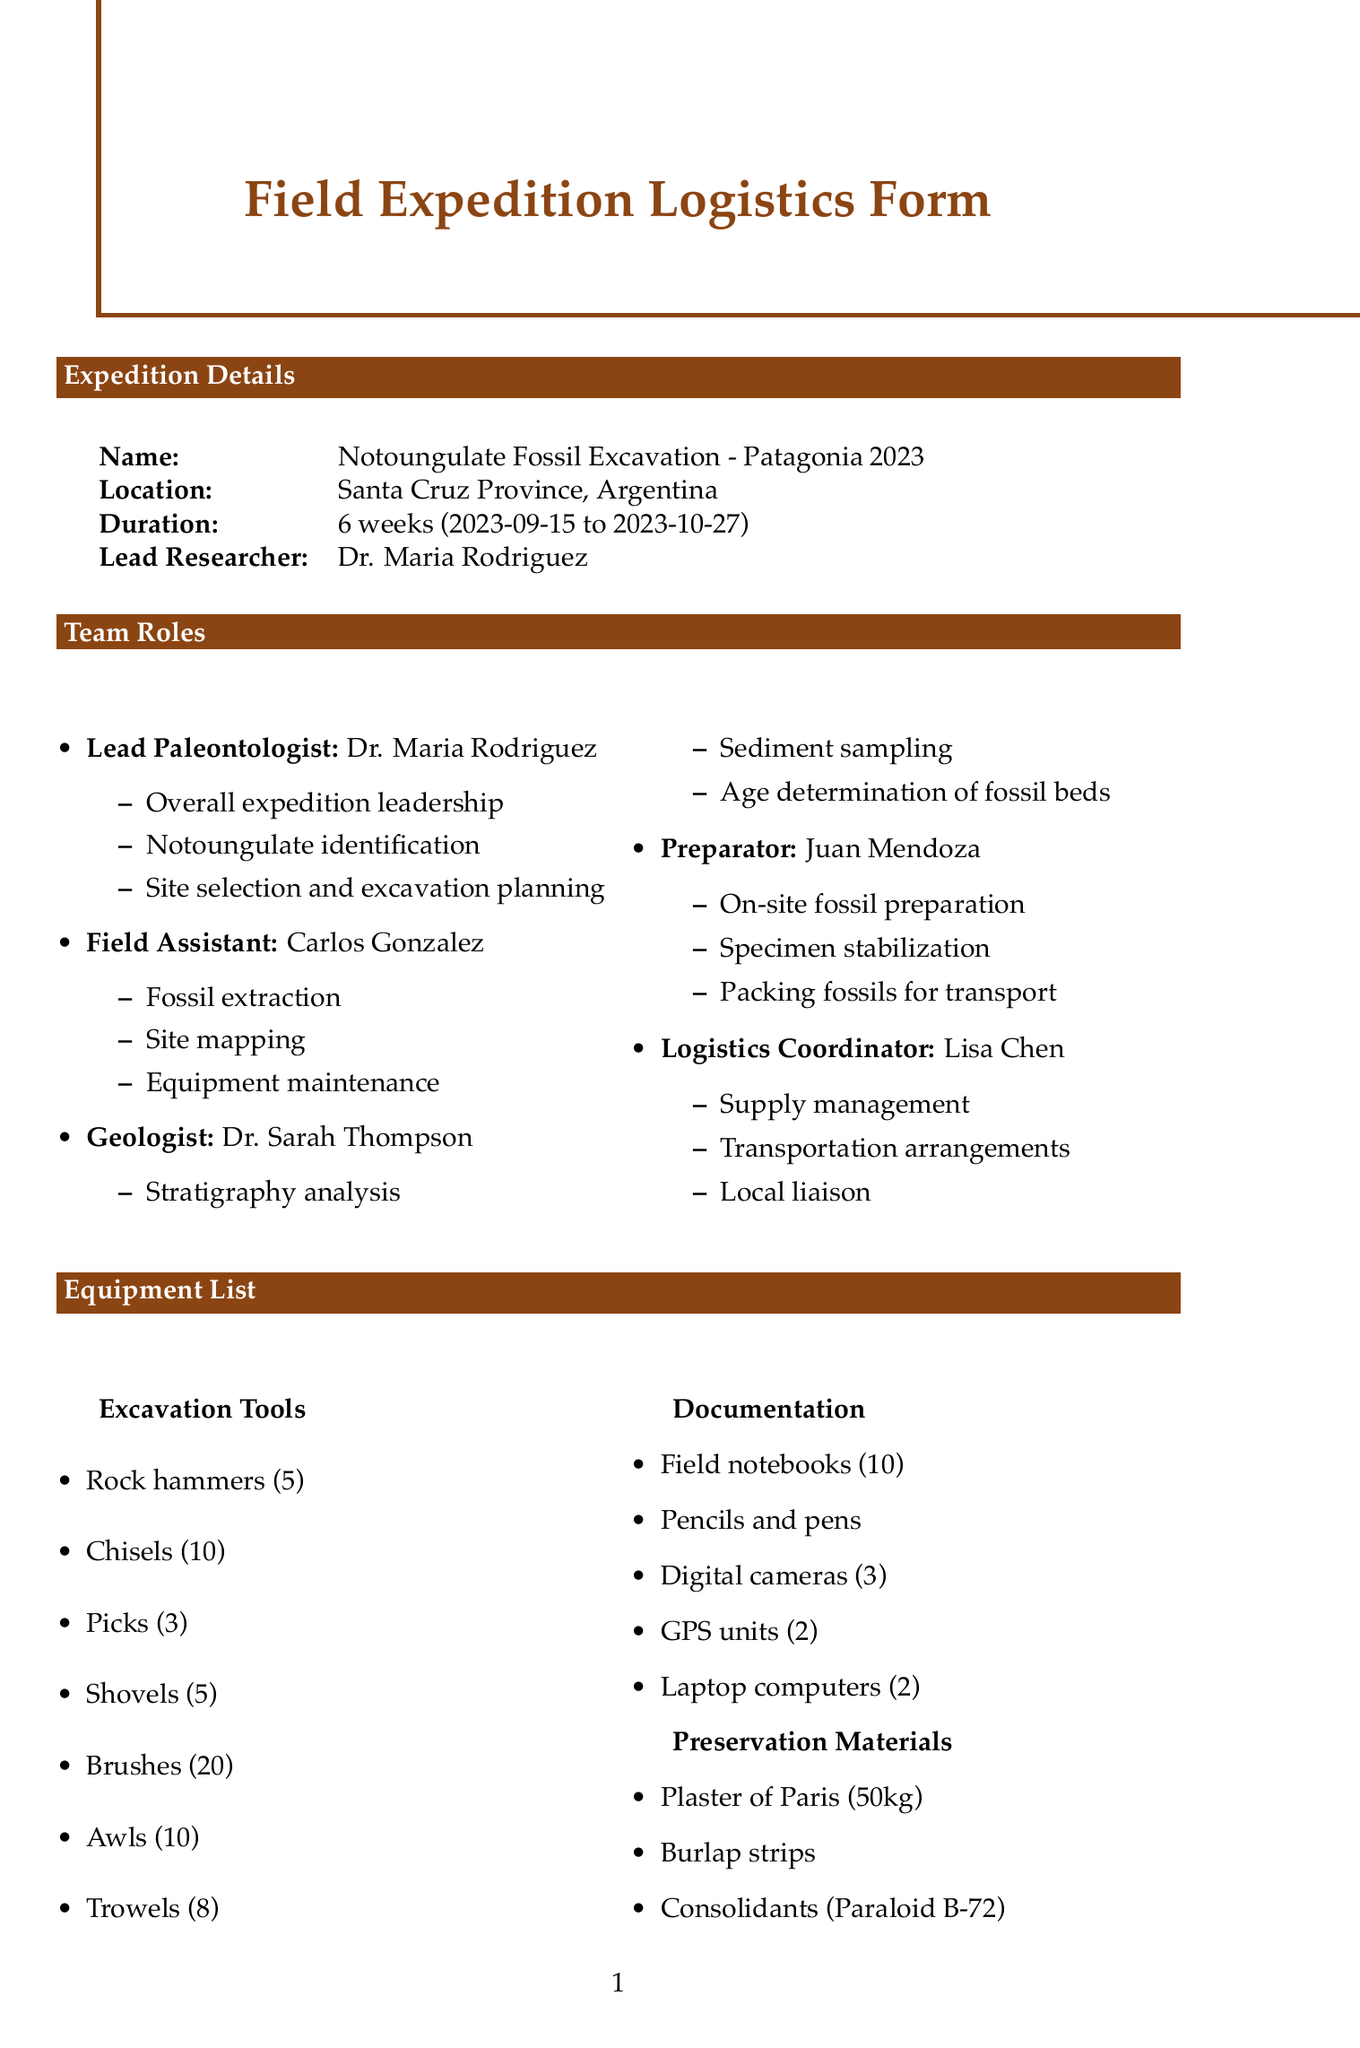What is the name of the expedition? The name of the expedition is provided in the document under expedition details.
Answer: Notoungulate Fossil Excavation - Patagonia 2023 Who is the lead researcher? The document specifies the role of the lead researcher and their name.
Answer: Dr. Maria Rodriguez What is the duration of the expedition? The duration of the expedition is mentioned in the expedition details section.
Answer: 6 weeks How many first aid kits are included in the equipment list? The equipment list specifies the number of first aid kits as part of safety equipment.
Answer: 3 What is the budget estimate for equipment and supplies? The budget estimate provides each category, and we can find the amount for equipment and supplies.
Answer: 20000 What kind of vehicle will be used for local transport? The document details the type of local transport needed for the expedition.
Answer: 4x4 vehicles What is the application deadline for the excavation permit? The document states the application deadline for the excavation permit under the permits section.
Answer: 2023-06-15 Name a local contact and their role. The document lists local contacts, mentioning their roles and affiliations.
Answer: Dr. Alberto Sanchez, Local collaborator and logistics support What specialized equipment will be used for aerial mapping? The specialized equipment section includes a specific item for aerial mapping.
Answer: Drone 